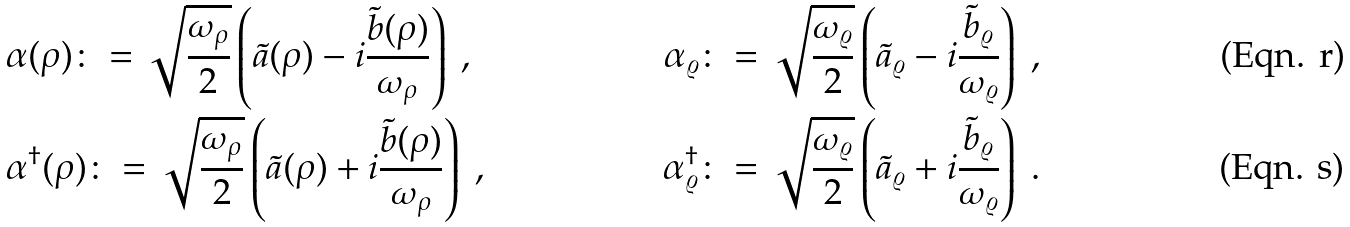<formula> <loc_0><loc_0><loc_500><loc_500>& { \alpha ( \rho ) \colon = \sqrt { \frac { \omega _ { \rho } } { 2 } } \left ( \tilde { a } ( \rho ) - i \frac { \tilde { b } ( \rho ) } { \omega _ { \rho } } \right ) \ , } & { \alpha _ { \varrho } \colon = \sqrt { \frac { \omega _ { \varrho } } { 2 } } \left ( \tilde { a } _ { \varrho } - i \frac { \tilde { b } _ { \varrho } } { \omega _ { \varrho } } \right ) \ , } \\ & { \alpha ^ { \dagger } ( \rho ) \colon = \sqrt { \frac { \omega _ { \rho } } { 2 } } \left ( \tilde { a } ( \rho ) + i \frac { \tilde { b } ( \rho ) } { \omega _ { \rho } } \right ) \ , } & { \alpha ^ { \dagger } _ { \varrho } \colon = \sqrt { \frac { \omega _ { \varrho } } { 2 } } \left ( \tilde { a } _ { \varrho } + i \frac { \tilde { b } _ { \varrho } } { \omega _ { \varrho } } \right ) \ . }</formula> 